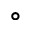<formula> <loc_0><loc_0><loc_500><loc_500>^ { \circ }</formula> 